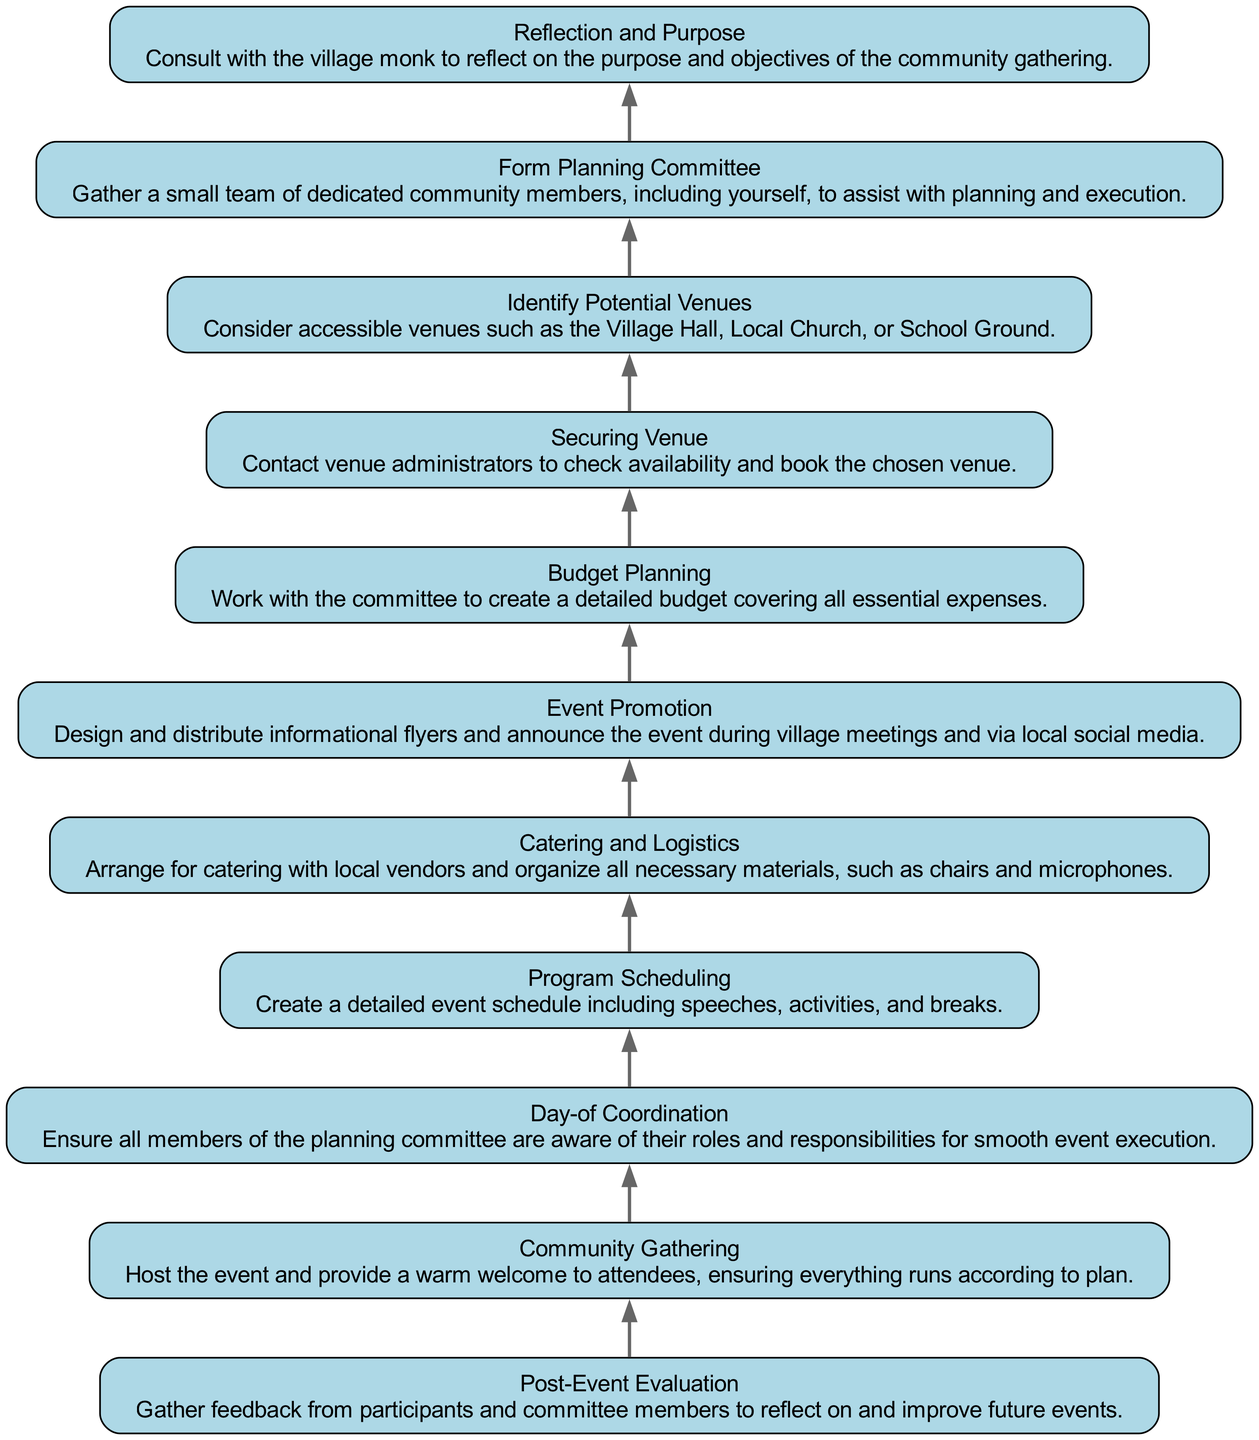What is the first step in organizing the community gathering? The first step is to consult with the village monk to reflect on the purpose and objectives of the community gathering. This is indicated as the bottom-most node in the flow chart, which represents the starting point of the process.
Answer: Reflection and Purpose How many total steps are in the flow chart? The flow chart consists of eleven steps, as seen when counting the individual nodes listed in the diagram, from the first step to the last step.
Answer: 11 What is the last step of the process? The last step is to gather feedback from participants and committee members to reflect on and improve future events. This is identified as the top-most node in the diagram, indicating the completion of the event process.
Answer: Post-Event Evaluation What does the node "Catering and Logistics" relate to in the process? The node "Catering and Logistics" is connected to the node "Event Promotion" and comes after "Budget Planning." It emphasizes that after budgeting, catering arrangements and logistics must be handled before the actual community gathering occurs.
Answer: Event Promotion What is formed just after the "Reflection and Purpose"? After completing the "Reflection and Purpose" step, the next action is the formation of a small team of dedicated community members to assist with planning and execution, signifying a collaborative effort right from the start.
Answer: Form Planning Committee Which step involves announcing the event via local social media? The step that involves announcing the event via local social media is "Event Promotion." This is identified because this node includes tasks related to creating awareness about the event.
Answer: Event Promotion What is necessary to secure the venue? To secure the venue, it is necessary to contact venue administrators to check availability and book the chosen venue. This is indicated in the step that follows identifying potential venues.
Answer: Securing Venue Which steps involve collaboration with the planning committee? The steps "Form Planning Committee," "Budget Planning," "Program Scheduling," and "Day-of Coordination" all involve collaboration with the planning committee, as they require input and action from the group gathered for the event.
Answer: Form Planning Committee, Budget Planning, Program Scheduling, Day-of Coordination What comes before the "Community Gathering" step? The step that comes immediately before "Community Gathering" is "Day-of Coordination," which entails ensuring all members are aware of their responsibilities for the smooth execution of the event.
Answer: Day-of Coordination 